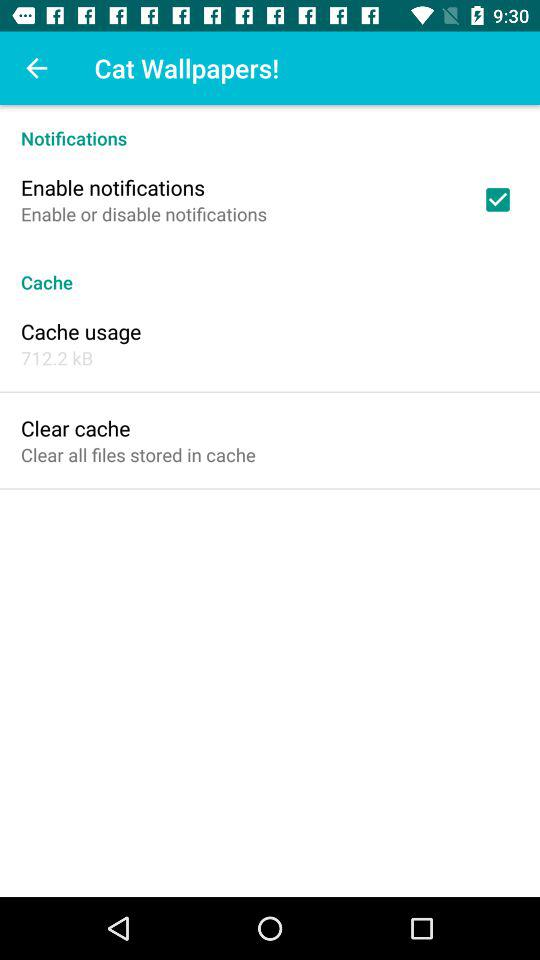What is the size of the cache memory? The size of the cache memory is 712.2 KB. 